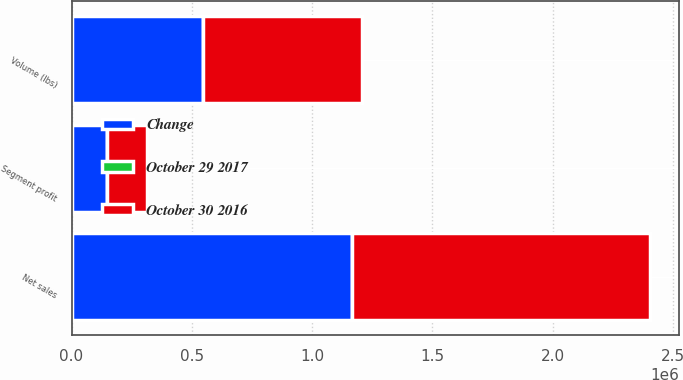<chart> <loc_0><loc_0><loc_500><loc_500><stacked_bar_chart><ecel><fcel>Volume (lbs)<fcel>Net sales<fcel>Segment profit<nl><fcel>Change<fcel>547196<fcel>1.16666e+06<fcel>145613<nl><fcel>October 30 2016<fcel>658506<fcel>1.23728e+06<fcel>168040<nl><fcel>October 29 2017<fcel>16.9<fcel>5.7<fcel>13.3<nl></chart> 